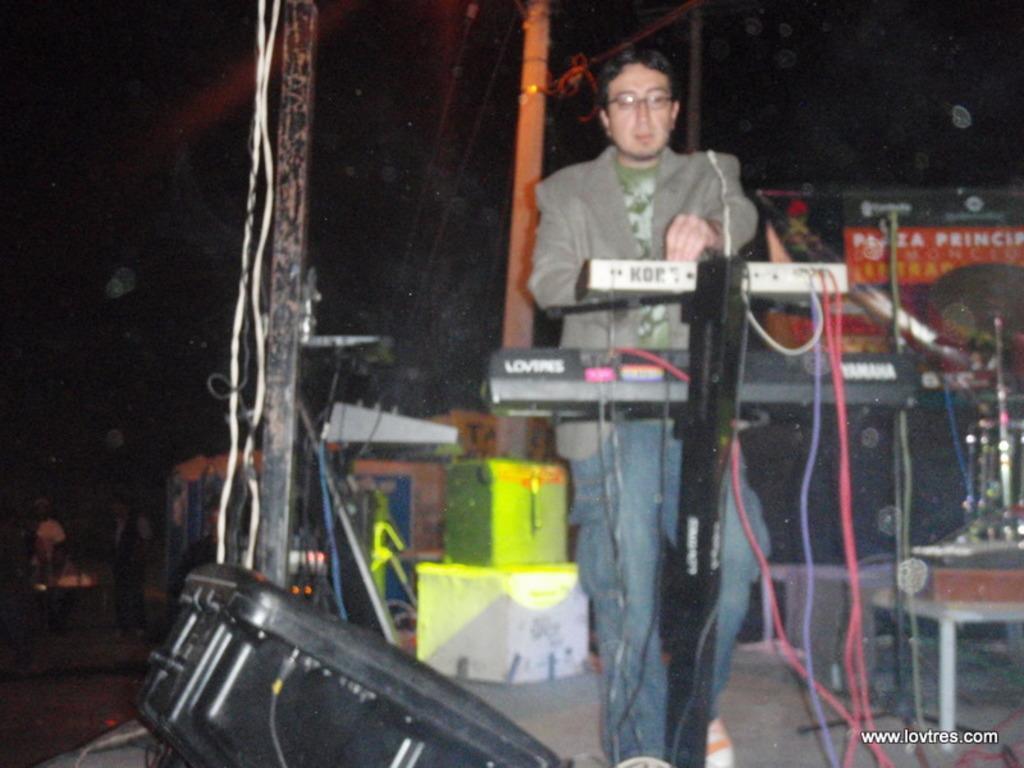Describe this image in one or two sentences. In the center of the image we can see a man standing, before him there is a piano. At the bottom we can see a speaker. On the left there are people and we can see poles and wires. On the right there is a band. In the background we can see a board. 